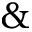Convert formula to latex. <formula><loc_0><loc_0><loc_500><loc_500>\&</formula> 